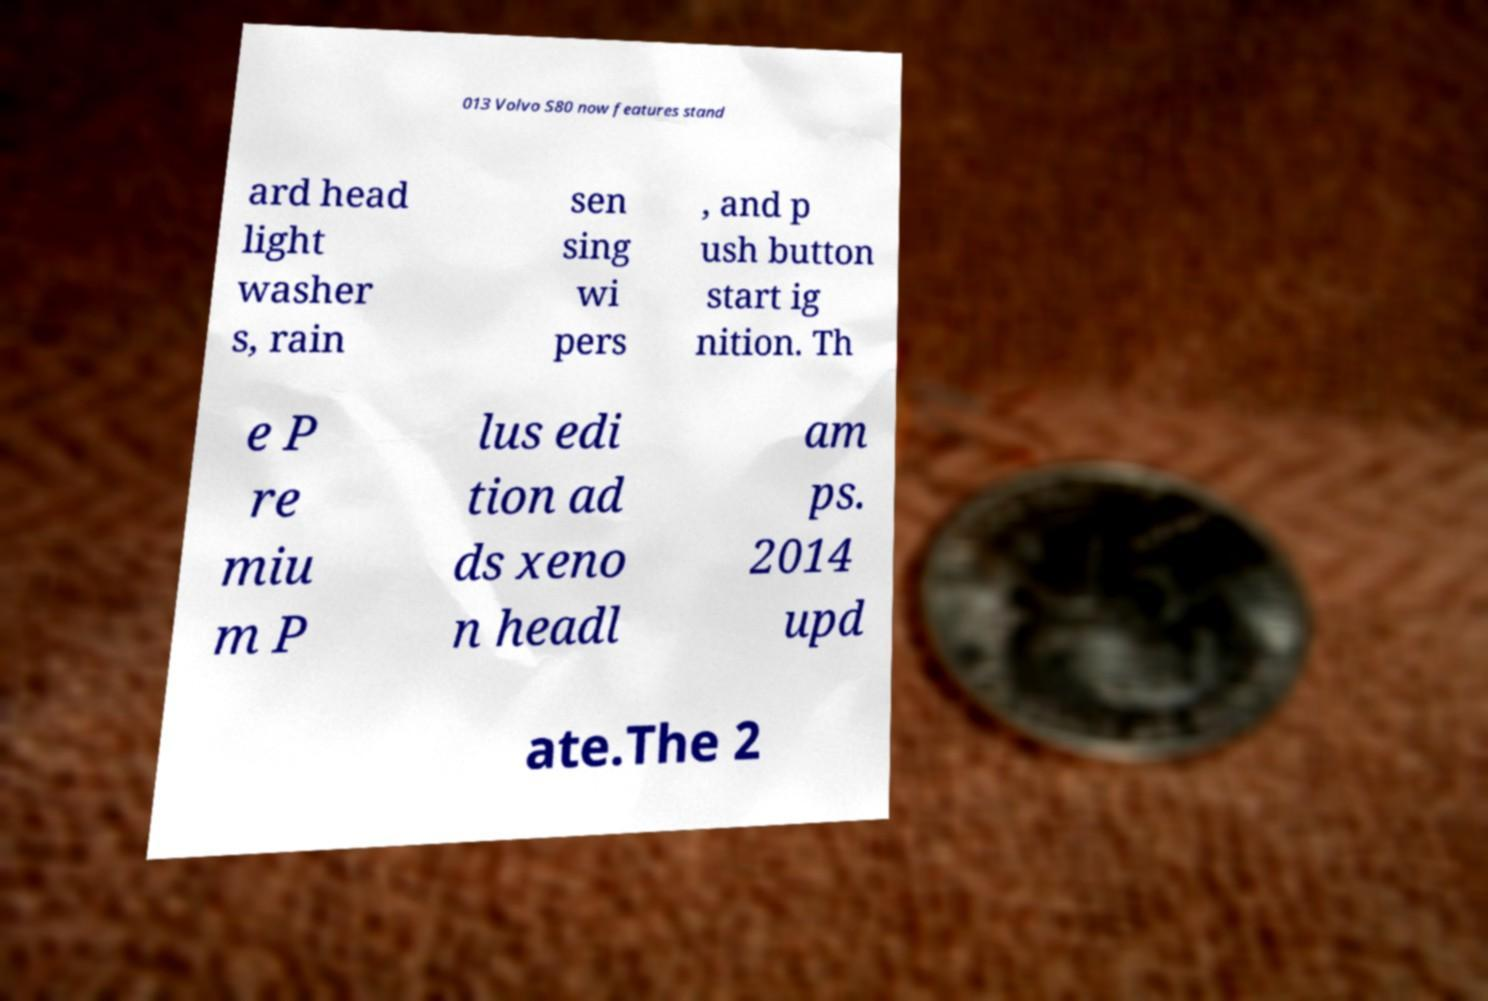Could you assist in decoding the text presented in this image and type it out clearly? 013 Volvo S80 now features stand ard head light washer s, rain sen sing wi pers , and p ush button start ig nition. Th e P re miu m P lus edi tion ad ds xeno n headl am ps. 2014 upd ate.The 2 